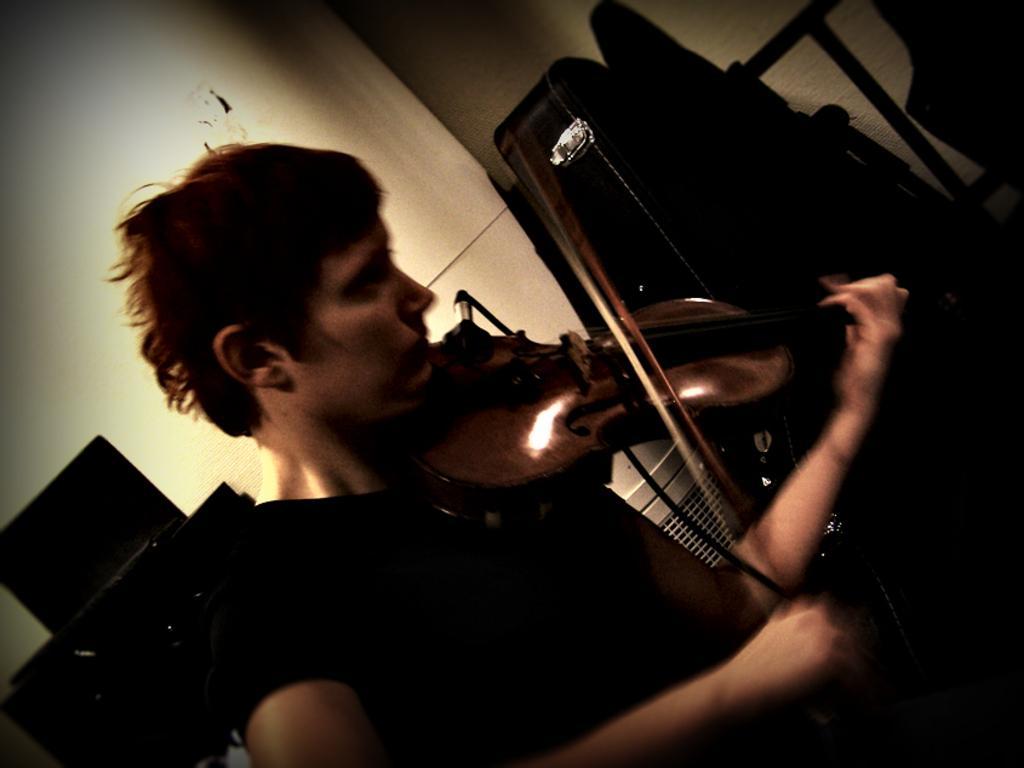Please provide a concise description of this image. This person is playing a violin. This is a violin bag. 